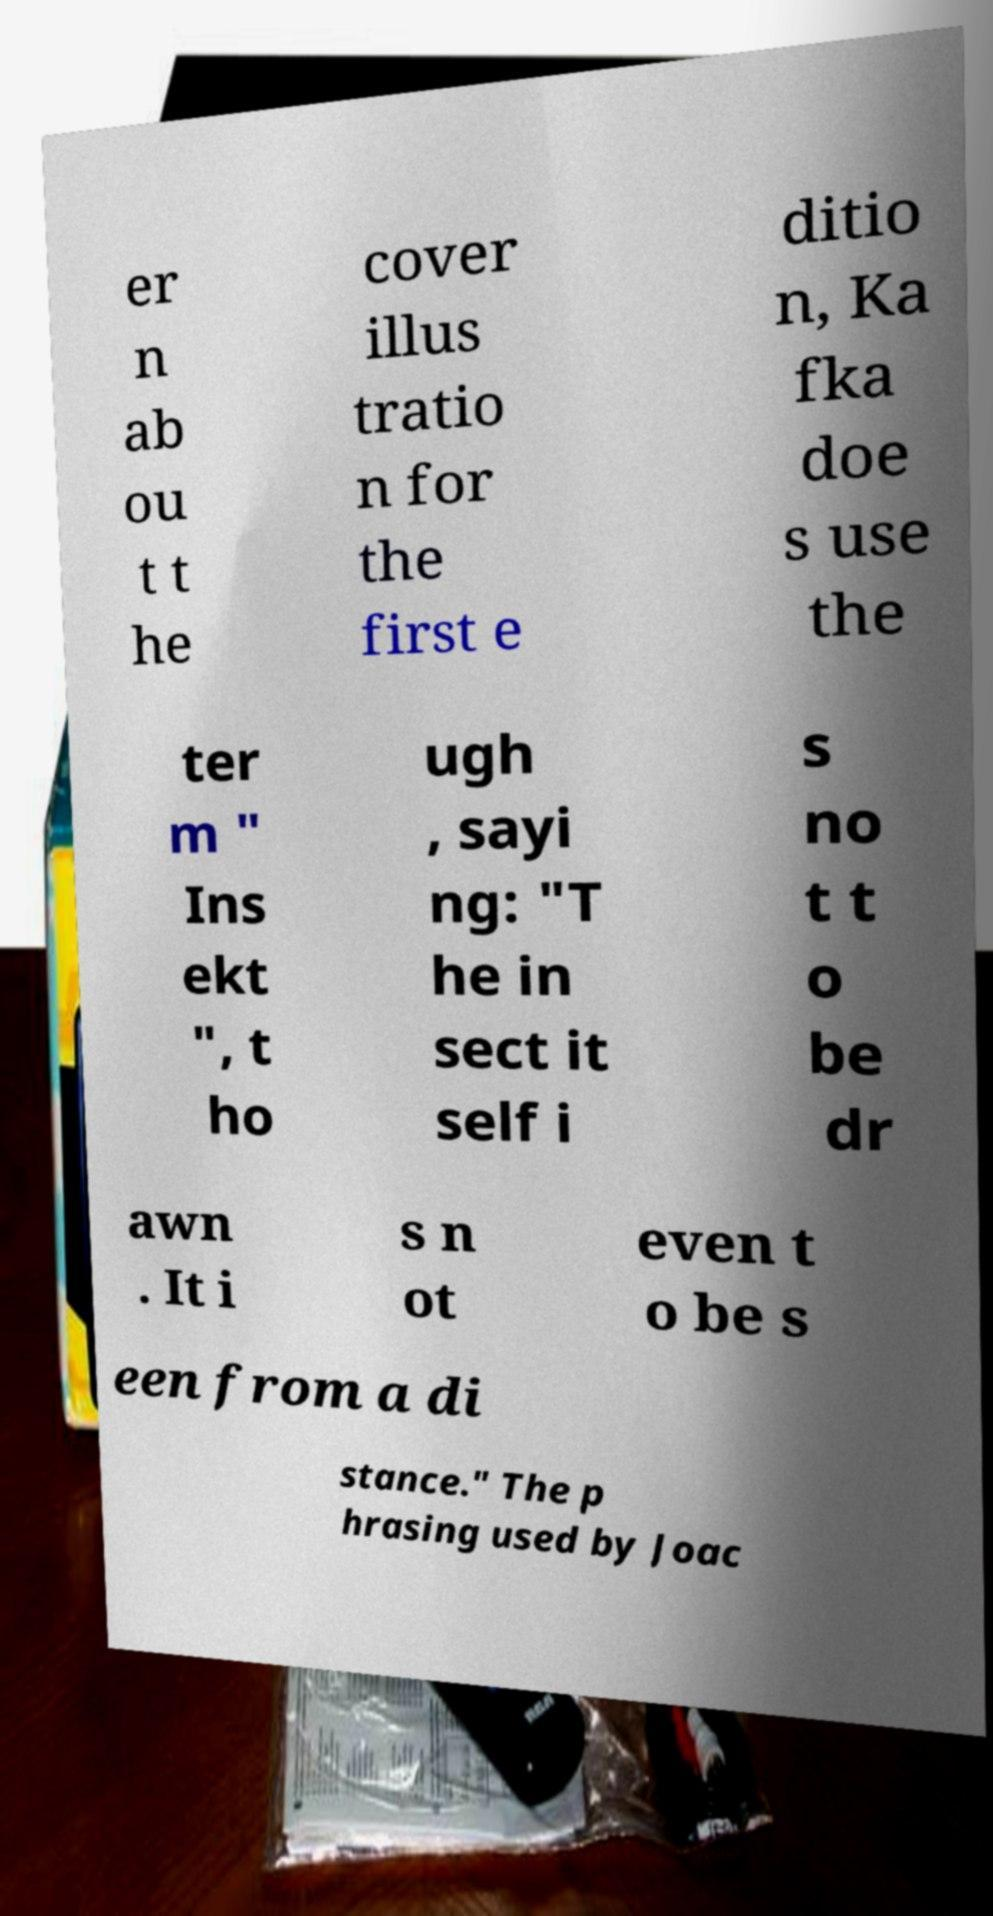What messages or text are displayed in this image? I need them in a readable, typed format. er n ab ou t t he cover illus tratio n for the first e ditio n, Ka fka doe s use the ter m " Ins ekt ", t ho ugh , sayi ng: "T he in sect it self i s no t t o be dr awn . It i s n ot even t o be s een from a di stance." The p hrasing used by Joac 